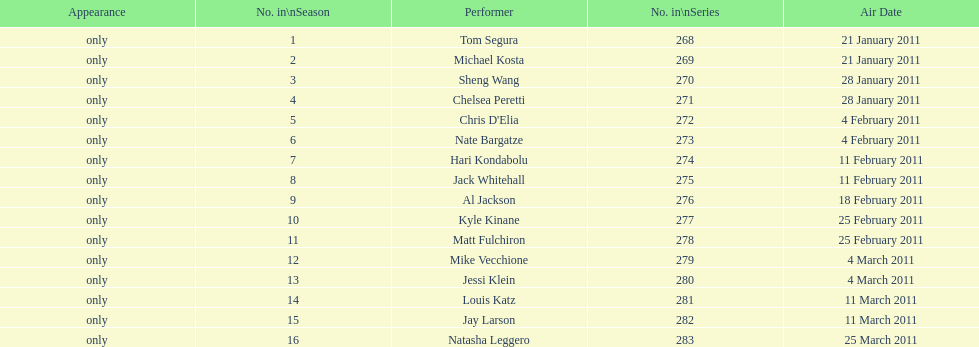What were the total number of air dates in february? 7. 